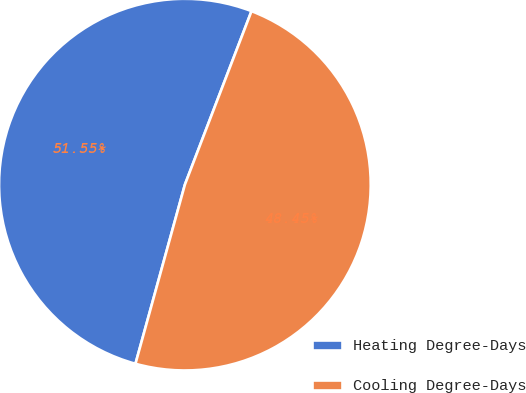<chart> <loc_0><loc_0><loc_500><loc_500><pie_chart><fcel>Heating Degree-Days<fcel>Cooling Degree-Days<nl><fcel>51.55%<fcel>48.45%<nl></chart> 